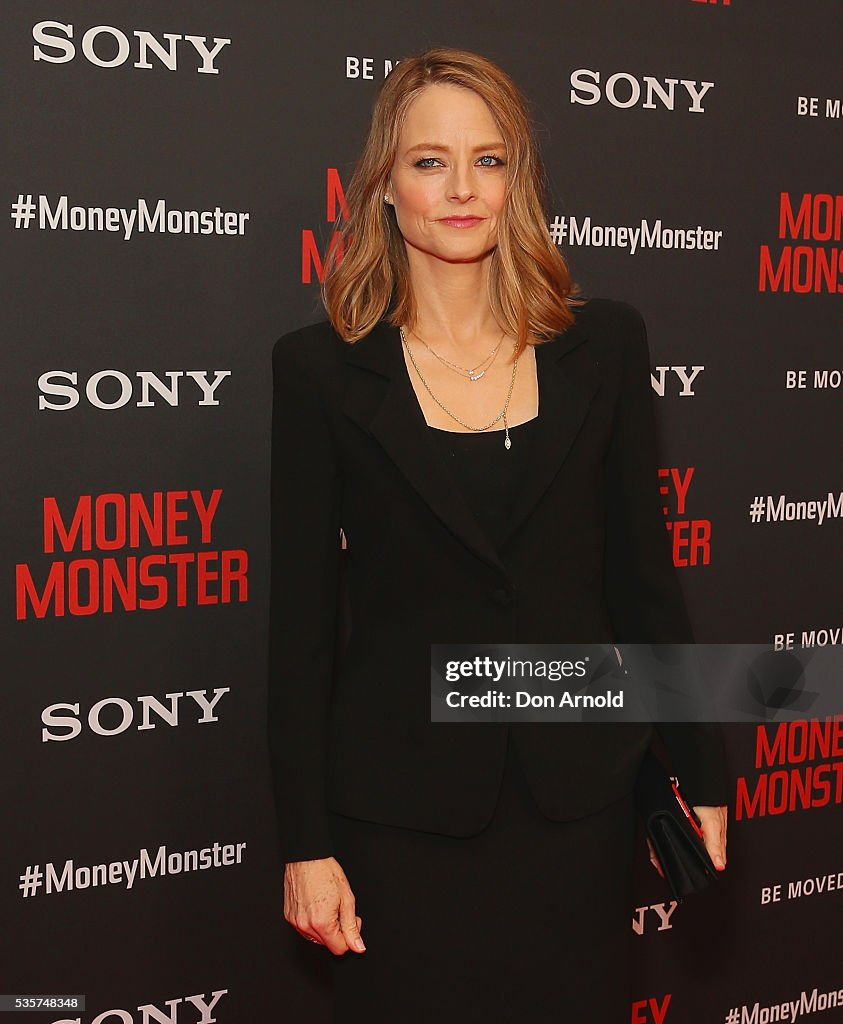Do you think this event is important for the attendees? Why or why not? Yes, events such as a movie premiere are highly significant for the attendees. For actors and crew members, it’s a celebration of their hard work and an opportunity to promote their project. For celebrities and VIPs, attending high-profile events can boost their public visibility and provide networking opportunities. For journalists and media, it’s a chance to capture exclusive content and interviews. The formal and meticulously planned nature of the event underscores its importance in the entertainment industry. Can you imagine a very casual question that someone might ask in this setting? Sure, a very casual question someone might ask in this setting could be, 'Who designed your outfit tonight?' I just want a quick description of what she's holding in her hand. She is holding a black clutch, a small handbag typically used for formal occasions to carry essentials such as a phone, keys, and makeup. 